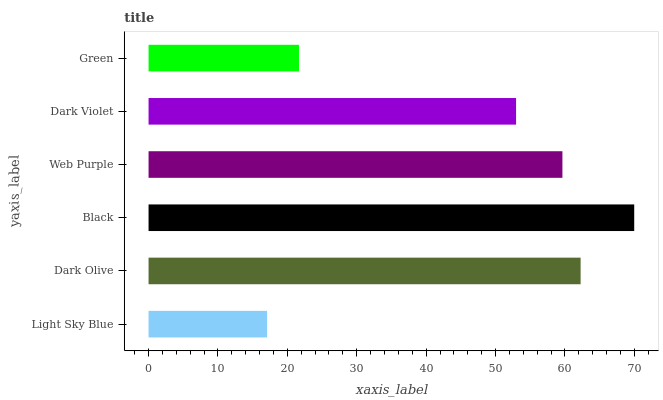Is Light Sky Blue the minimum?
Answer yes or no. Yes. Is Black the maximum?
Answer yes or no. Yes. Is Dark Olive the minimum?
Answer yes or no. No. Is Dark Olive the maximum?
Answer yes or no. No. Is Dark Olive greater than Light Sky Blue?
Answer yes or no. Yes. Is Light Sky Blue less than Dark Olive?
Answer yes or no. Yes. Is Light Sky Blue greater than Dark Olive?
Answer yes or no. No. Is Dark Olive less than Light Sky Blue?
Answer yes or no. No. Is Web Purple the high median?
Answer yes or no. Yes. Is Dark Violet the low median?
Answer yes or no. Yes. Is Dark Olive the high median?
Answer yes or no. No. Is Dark Olive the low median?
Answer yes or no. No. 